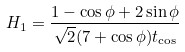Convert formula to latex. <formula><loc_0><loc_0><loc_500><loc_500>H _ { 1 } = \frac { 1 - \cos \phi + 2 \sin \phi } { \sqrt { 2 } ( 7 + \cos \phi ) t _ { \cos } }</formula> 